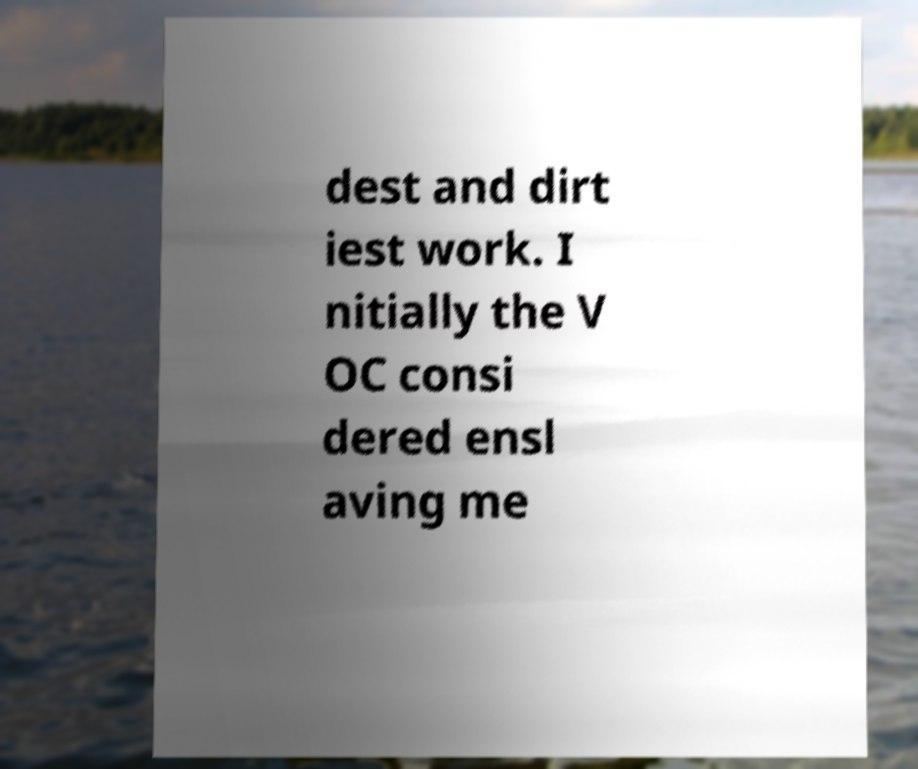There's text embedded in this image that I need extracted. Can you transcribe it verbatim? dest and dirt iest work. I nitially the V OC consi dered ensl aving me 